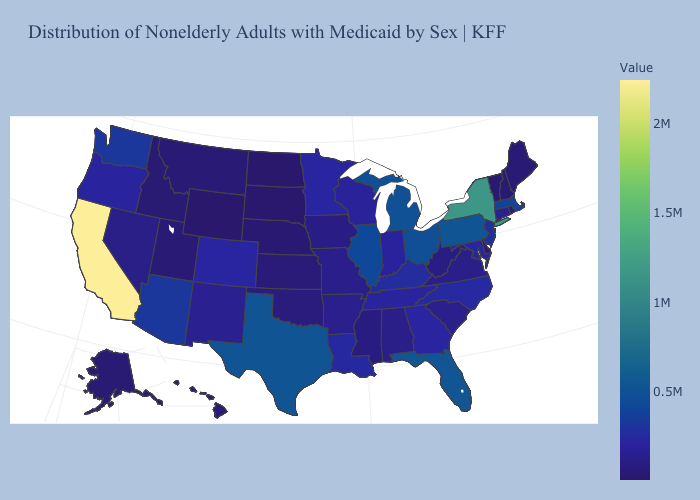Does California have the highest value in the USA?
Give a very brief answer. Yes. Which states have the lowest value in the South?
Concise answer only. Delaware. Does the map have missing data?
Give a very brief answer. No. Does California have the highest value in the USA?
Give a very brief answer. Yes. Among the states that border Maine , which have the highest value?
Write a very short answer. New Hampshire. Among the states that border Maryland , does Delaware have the lowest value?
Keep it brief. Yes. Does Ohio have the lowest value in the USA?
Answer briefly. No. 